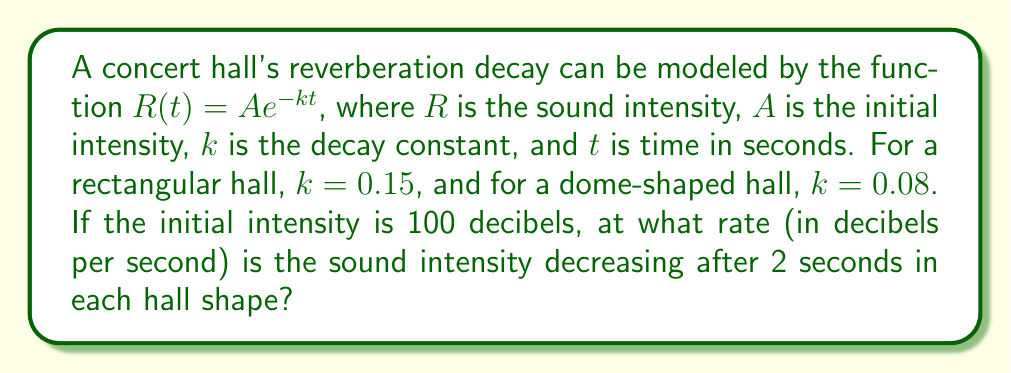Could you help me with this problem? To solve this problem, we need to find the rate of change of the sound intensity at $t = 2$ seconds for both hall shapes. We'll use the derivative of the function to determine this rate.

Step 1: Express the function for each hall shape.
Rectangular hall: $R_r(t) = 100e^{-0.15t}$
Dome-shaped hall: $R_d(t) = 100e^{-0.08t}$

Step 2: Find the derivative of the general function $R(t) = Ae^{-kt}$.
$$\frac{dR}{dt} = A \cdot (-k) \cdot e^{-kt} = -Ake^{-kt}$$

Step 3: Apply the derivative to each hall shape.
Rectangular hall: $\frac{dR_r}{dt} = -100 \cdot 0.15 \cdot e^{-0.15t}$
Dome-shaped hall: $\frac{dR_d}{dt} = -100 \cdot 0.08 \cdot e^{-0.08t}$

Step 4: Evaluate the rate of change at $t = 2$ seconds for each hall.
Rectangular hall:
$$\frac{dR_r}{dt}(2) = -15 \cdot e^{-0.3} \approx -11.11 \text{ dB/s}$$

Dome-shaped hall:
$$\frac{dR_d}{dt}(2) = -8 \cdot e^{-0.16} \approx -6.84 \text{ dB/s}$$

The negative signs indicate that the sound intensity is decreasing.
Answer: Rectangular hall: -11.11 dB/s; Dome-shaped hall: -6.84 dB/s 